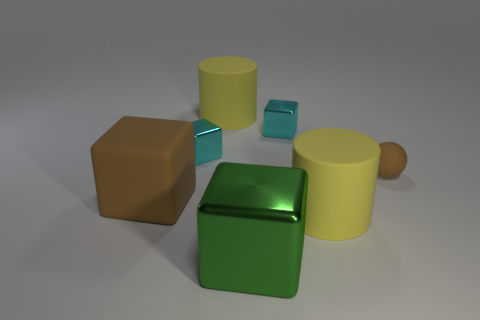What number of small things are either brown things or blue blocks?
Provide a short and direct response. 1. There is a green cube; is it the same size as the brown thing on the left side of the large shiny cube?
Make the answer very short. Yes. Are there any other things that have the same shape as the big green metallic thing?
Provide a short and direct response. Yes. What number of tiny green objects are there?
Offer a terse response. 0. What number of gray things are either large metallic things or rubber cubes?
Provide a succinct answer. 0. Are the large green cube that is in front of the tiny brown sphere and the brown sphere made of the same material?
Offer a very short reply. No. How many other things are the same material as the big green object?
Keep it short and to the point. 2. What material is the big green cube?
Your answer should be very brief. Metal. What is the size of the yellow rubber cylinder that is behind the small brown ball?
Your response must be concise. Large. There is a cyan metallic block that is to the right of the large green metallic object; how many small things are to the right of it?
Provide a short and direct response. 1. 